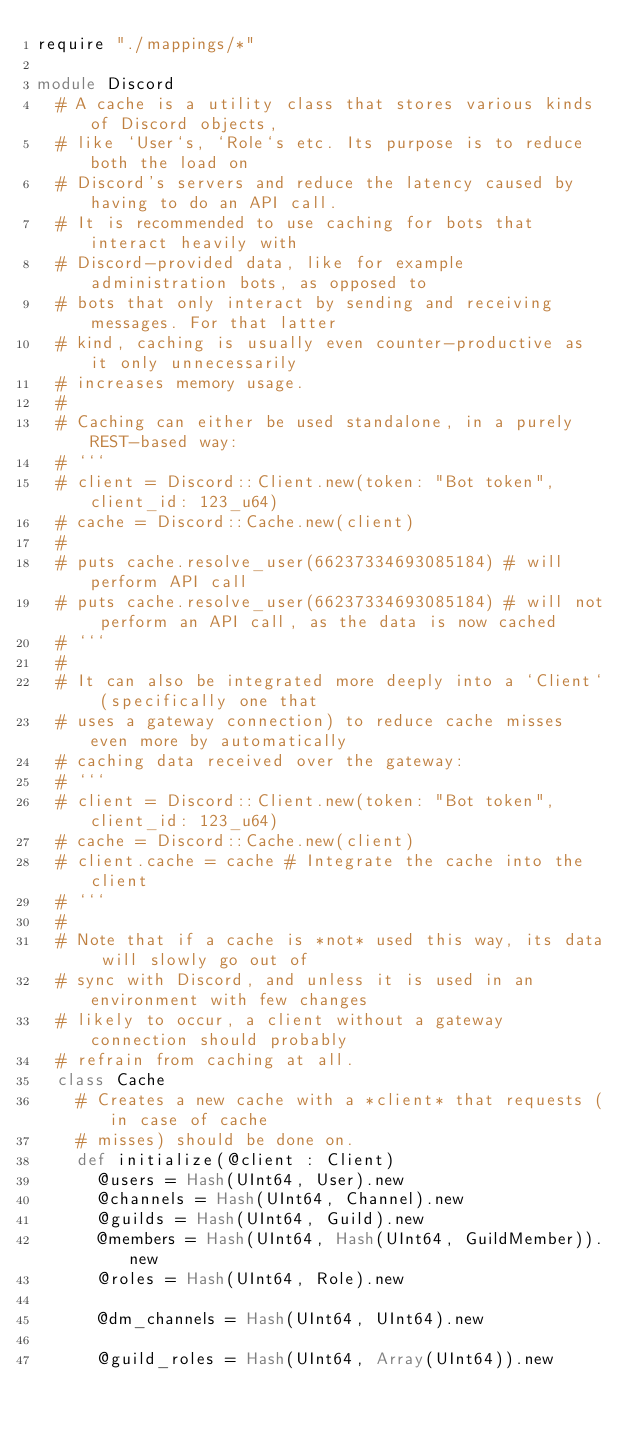Convert code to text. <code><loc_0><loc_0><loc_500><loc_500><_Crystal_>require "./mappings/*"

module Discord
  # A cache is a utility class that stores various kinds of Discord objects,
  # like `User`s, `Role`s etc. Its purpose is to reduce both the load on
  # Discord's servers and reduce the latency caused by having to do an API call.
  # It is recommended to use caching for bots that interact heavily with
  # Discord-provided data, like for example administration bots, as opposed to
  # bots that only interact by sending and receiving messages. For that latter
  # kind, caching is usually even counter-productive as it only unnecessarily
  # increases memory usage.
  #
  # Caching can either be used standalone, in a purely REST-based way:
  # ```
  # client = Discord::Client.new(token: "Bot token", client_id: 123_u64)
  # cache = Discord::Cache.new(client)
  #
  # puts cache.resolve_user(66237334693085184) # will perform API call
  # puts cache.resolve_user(66237334693085184) # will not perform an API call, as the data is now cached
  # ```
  #
  # It can also be integrated more deeply into a `Client` (specifically one that
  # uses a gateway connection) to reduce cache misses even more by automatically
  # caching data received over the gateway:
  # ```
  # client = Discord::Client.new(token: "Bot token", client_id: 123_u64)
  # cache = Discord::Cache.new(client)
  # client.cache = cache # Integrate the cache into the client
  # ```
  #
  # Note that if a cache is *not* used this way, its data will slowly go out of
  # sync with Discord, and unless it is used in an environment with few changes
  # likely to occur, a client without a gateway connection should probably
  # refrain from caching at all.
  class Cache
    # Creates a new cache with a *client* that requests (in case of cache
    # misses) should be done on.
    def initialize(@client : Client)
      @users = Hash(UInt64, User).new
      @channels = Hash(UInt64, Channel).new
      @guilds = Hash(UInt64, Guild).new
      @members = Hash(UInt64, Hash(UInt64, GuildMember)).new
      @roles = Hash(UInt64, Role).new

      @dm_channels = Hash(UInt64, UInt64).new

      @guild_roles = Hash(UInt64, Array(UInt64)).new</code> 